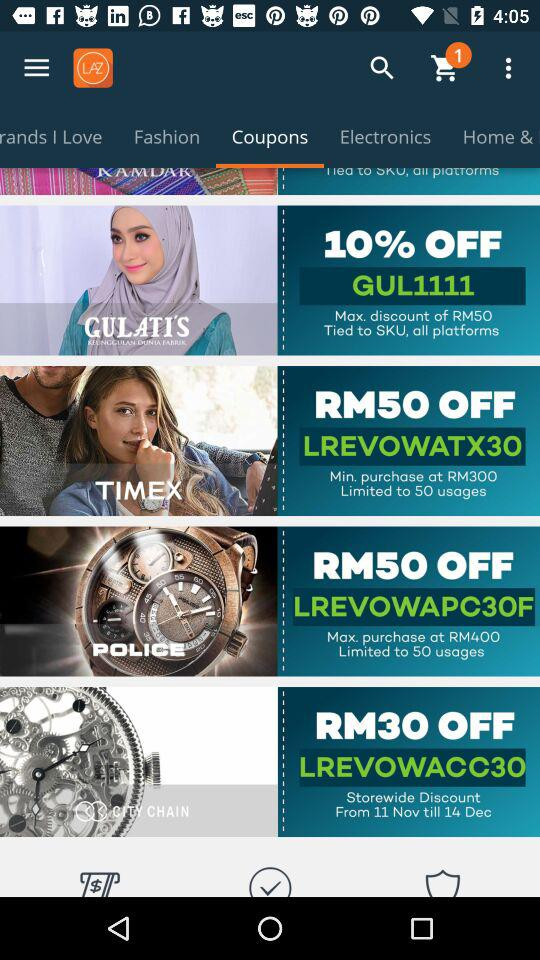How many items are in the shopping cart?
Answer the question using a single word or phrase. 1 